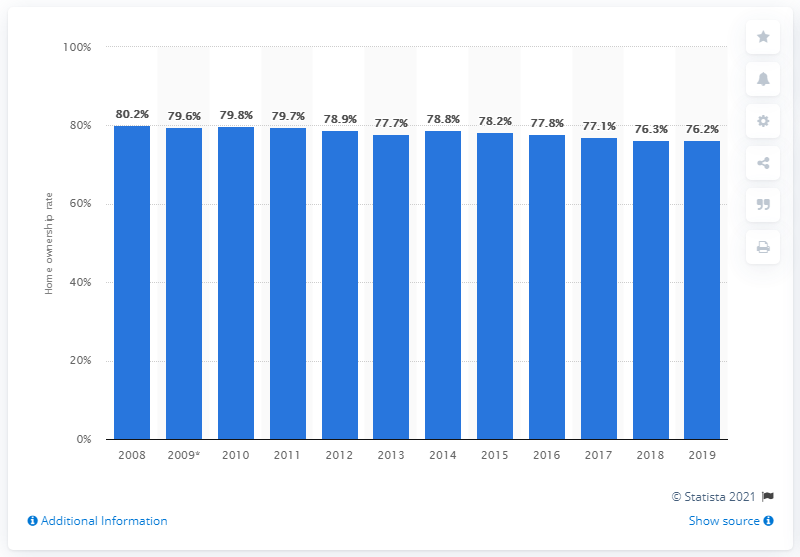Point out several critical features in this image. During the period of 2008 to 2019, the home ownership rate in Spain was 76.3%. 